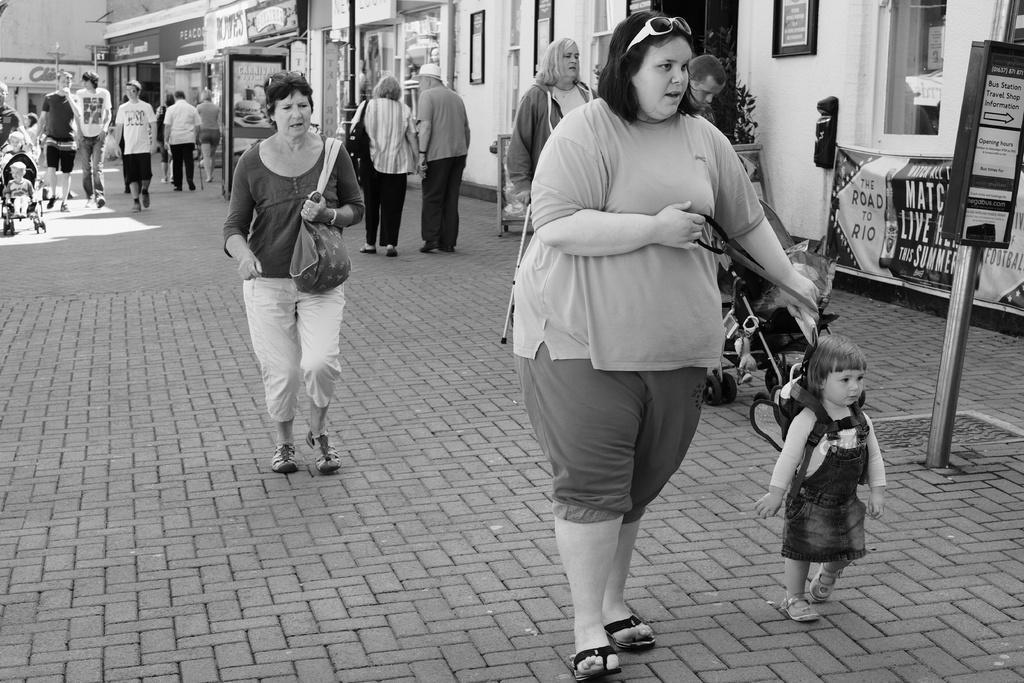Please provide a concise description of this image. In this picture there is a woman who is wearing goggles, t-shirt, short and slipper. She is holding baby who is wearing bag and black dress. On the left there is a woman who is holding bag. In the background we can see the group of person standing near to the shop and buildings. At the top we can see photo frames on the wall. On the right we can see banners and posters near to the window. 